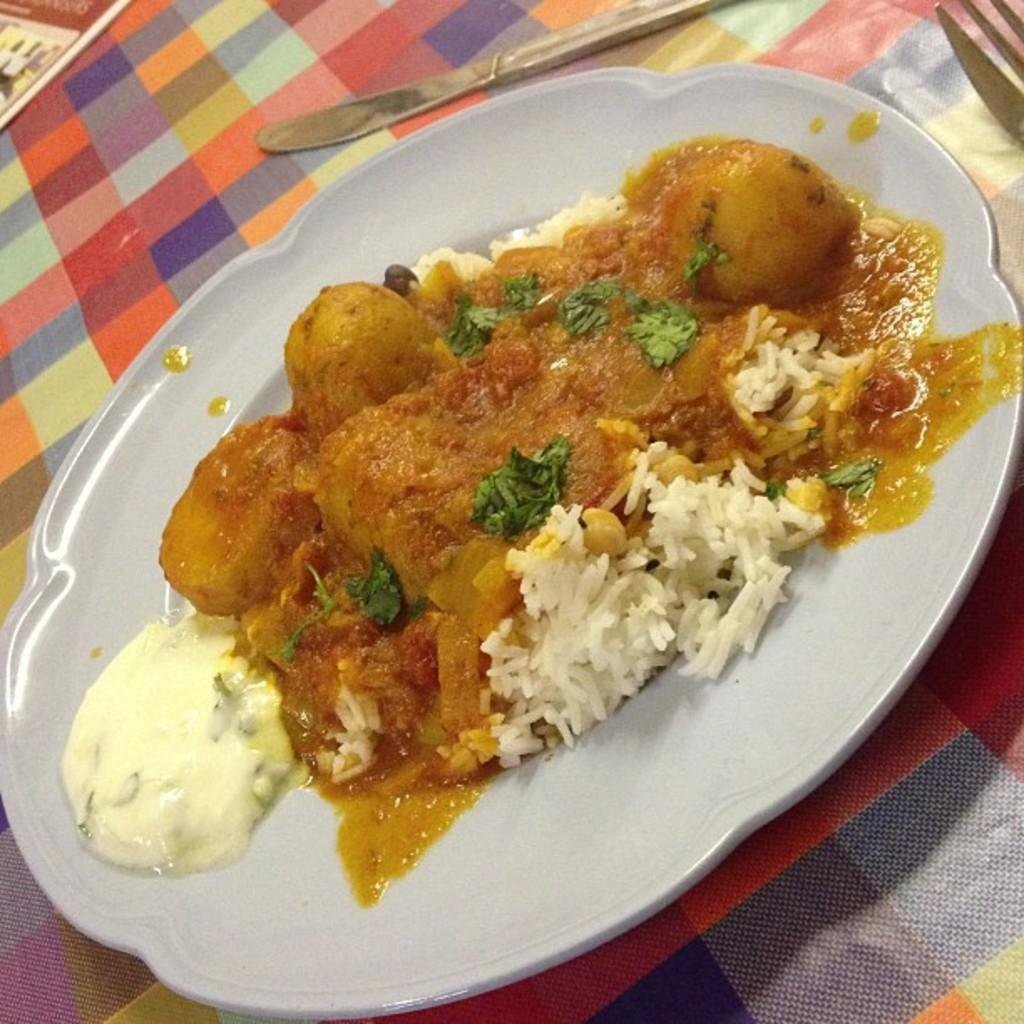What object is present on the plate in the image? There is a food item on the plate in the image. What is the color of the plate? The plate is white in color. What utensils are visible in the image? There is a knife and a fork in the image. How does the goat react to the surprise in the image? There is no goat or surprise present in the image. 